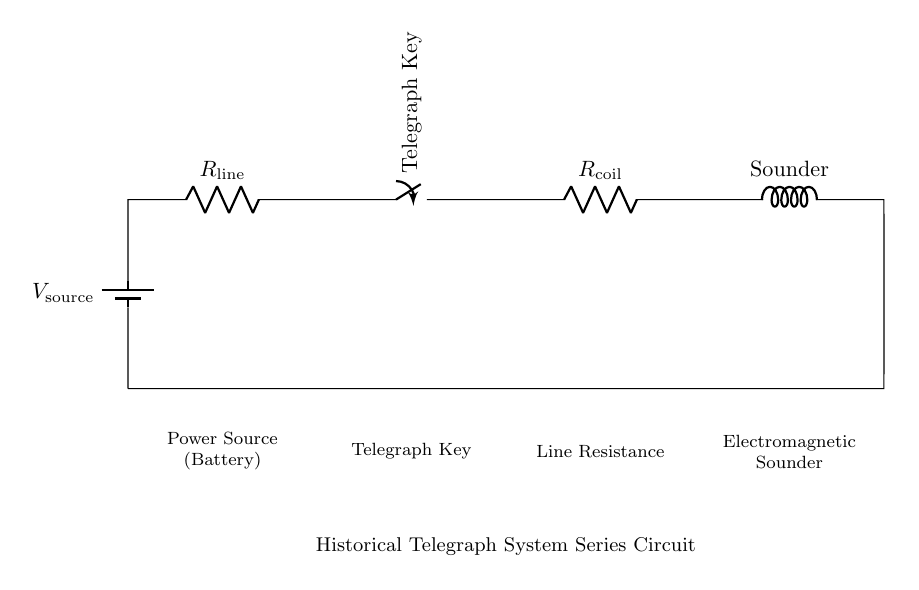What type of component is represented by the telegraph key? The telegraph key is a switch that controls the flow of current in the circuit. It can open or close the circuit, allowing the signal to be sent or interrupted.
Answer: Switch What is the purpose of the electromagnetic sounder? The electromagnetic sounder converts electrical signals into sound, providing an auditory signal (click) when current passes through it, which indicates receipt of a message.
Answer: Sound How many resistors are present in this circuit? There are two resistors in the circuit: one is the line resistance and the other is the coil resistance of the sounder.
Answer: Two What happens when the telegraph key is closed? When the telegraph key is closed, the circuit becomes complete, allowing current to flow through the entire circuit, activating the sounder and producing sound.
Answer: Current flows What is the total resistance in the circuit when the telegraph key is closed? The total resistance is the sum of the line resistance and the coil resistance because they are in series. Thus, total resistance equals R line plus R coil.
Answer: R line + R coil Why is the circuit arranged in series rather than parallel? In a series circuit, the current is the same throughout all components, which is essential for telegraph systems to ensure that the signals are transmitted effectively and uniformly across long distances.
Answer: To ensure uniform current 